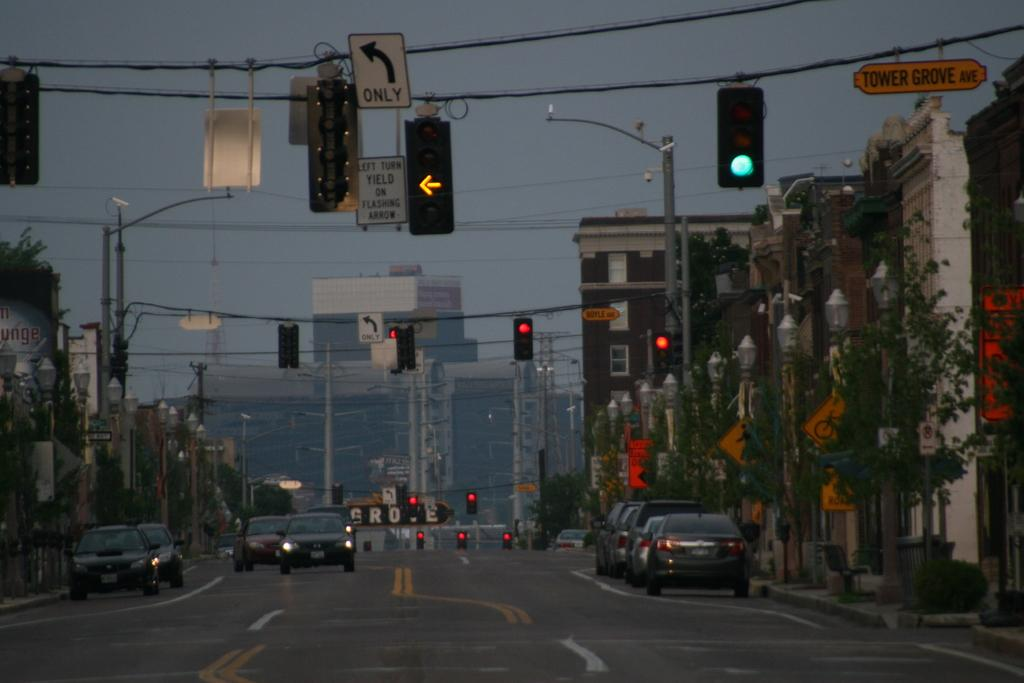Provide a one-sentence caption for the provided image. An intersection with a yellow left turn arrow and a sign that says left turn yield on flashing arrow. 